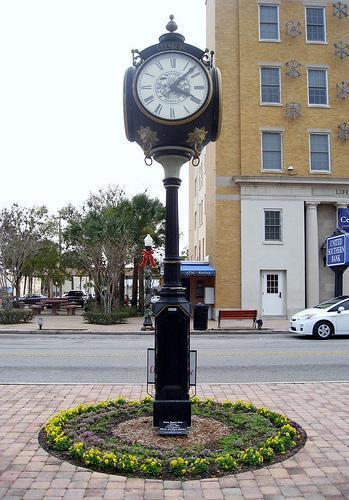How many clocks are in this photo?
Give a very brief answer. 1. 